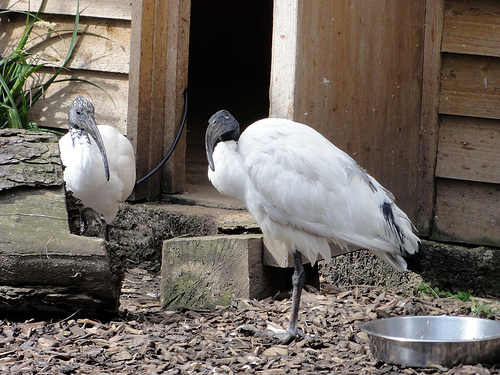<image>
Can you confirm if the bird is next to the doorway? Yes. The bird is positioned adjacent to the doorway, located nearby in the same general area. Is the bird in front of the siding? Yes. The bird is positioned in front of the siding, appearing closer to the camera viewpoint. 